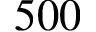<formula> <loc_0><loc_0><loc_500><loc_500>5 0 0</formula> 